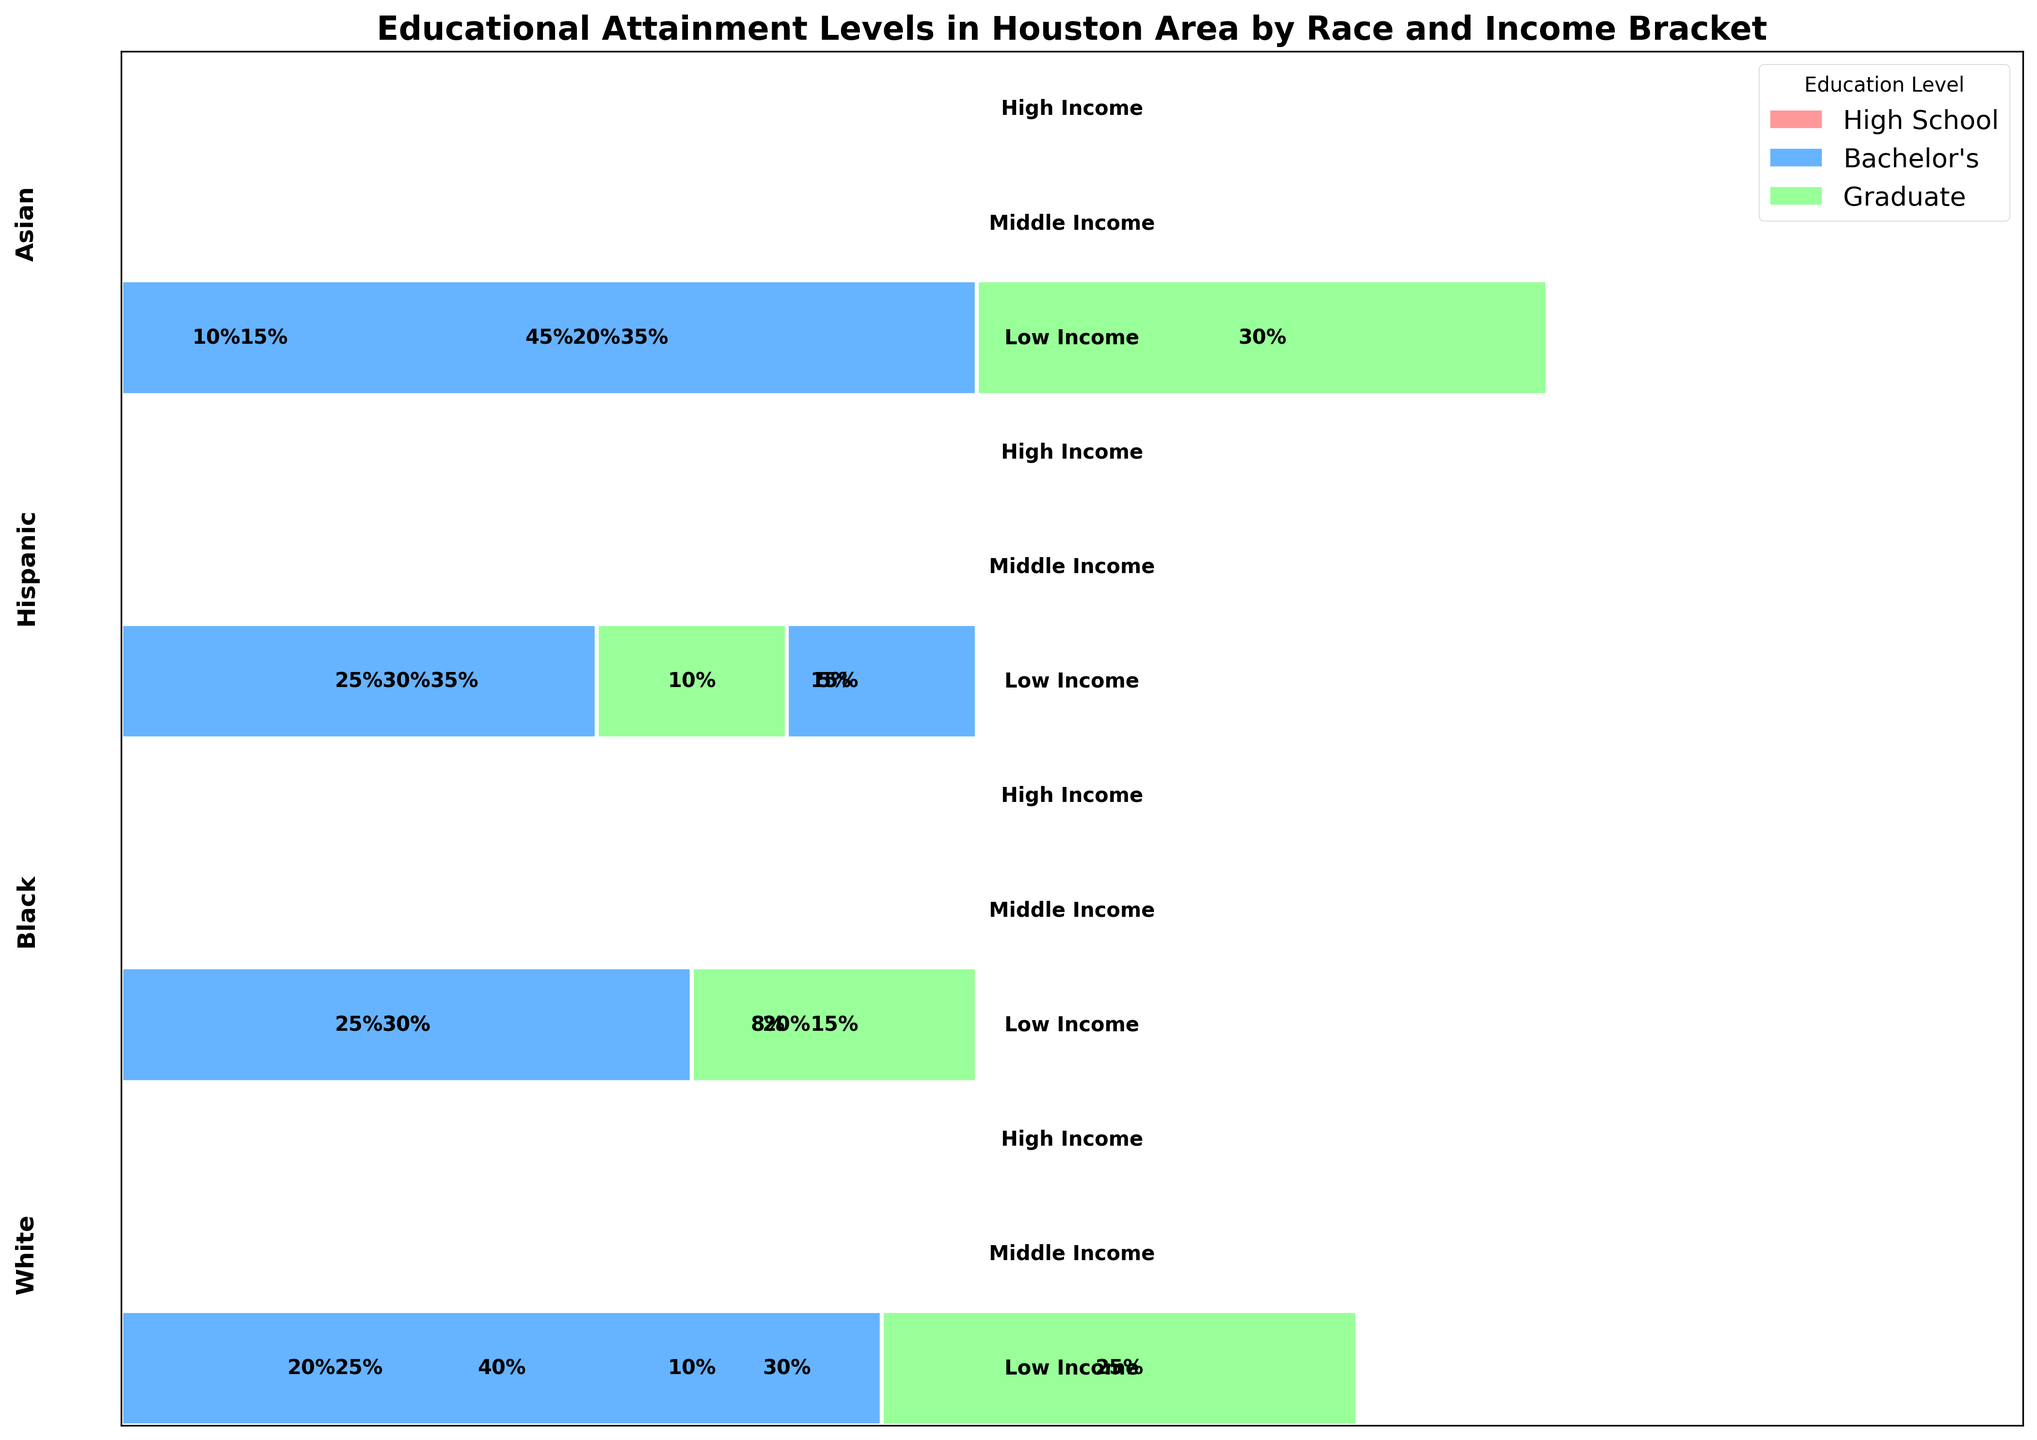How many income brackets are considered in the plot? The plot categorizes data into different income brackets. In the plot, there are segments labeled as "Low Income," "Middle Income," and "High Income," indicating three distinct income brackets.
Answer: Three Which race has the highest percentage of Bachelor’s degrees within the High Income bracket? To determine this, we need to inspect the High Income bracket across all races and compare the percentages for Bachelor's degrees. For White, it's 40%; for Black, 30%; for Hispanic, 25%; and for Asian, 45%. The Asian race has the highest percentage of Bachelor's degrees within the High Income bracket.
Answer: Asian What is the total percentage of White individuals with at least a Bachelor’s degree in all income brackets combined? Sum the percentages of White individuals with Bachelor's degrees in all income brackets: Low Income (10%), Middle Income (30%), and High Income (40%). Add these together: 10 + 30 + 40 = 80%. Additionally, sum those with Graduate degrees in the High Income bracket (25%): 80 + 25 = 105%. Thus, the total percentage is 105%.
Answer: 105% Compare the percentage of Hispanic individuals with a Bachelor’s degree in the Middle Income bracket to Black individuals in the same bracket. Which is higher and by how much? The plot shows that the percentage of Hispanic individuals with a Bachelor's degree in the Middle Income bracket is 15%, and for Black individuals, it's 20%. To find the difference, subtract 15% from 20%: 20 - 15 = 5%. Thus, Black individuals have a higher percentage by 5%.
Answer: Black, by 5% Which education level shows the most significant percentage increase from Low Income to High Income for Asian individuals? To find the most significant percentage increase, examine the percentages for each education level within Low Income and High Income brackets for Asians: 
For High School: 15% (Low Income) to 0% (High Income), change: -15%
For Bachelor's: 20% (Low Income) to 45% (High Income), change: 25%
For Graduate: 0% (Low Income) to 30% (High Income), change: 30%
The Graduate education level shows the most significant increase by 30%.
Answer: Graduate What is the percentage of Black individuals with a High School education in the Low Income bracket compared to all other brackets? In the Low Income bracket, Black individuals with a High School education make up 30%. Within the Middle Income bracket, they make up 25%. There isn't a specified High School percentage for the High Income bracket in the provided dataset. So, the Low Income percentage is 30%, and Middle Income is 25%.
Answer: Low Income: 30%, Middle Income: 25% What race has the most balanced distribution of educational attainment across all income brackets? To determine this, we need to assess the distribution of educational levels within Low, Middle, and High Income brackets for each race and see which race has the closest percentages across all categories. Hispanic individuals show the following distribution:
Low Income: High School (35%), Bachelor's (5%),
Middle Income: High School (30%), Bachelor's (15%),
High Income: Bachelor's (25%), Graduate (10%).
This indicates a somewhat balanced but slightly lower attainment at higher education levels. The distribution for Asians is relatively more balanced despite higher Bachelor's and Graduate percentages.
Answer: Asians 